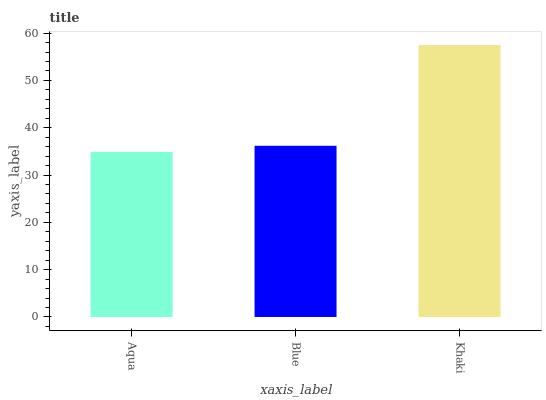Is Aqua the minimum?
Answer yes or no. Yes. Is Khaki the maximum?
Answer yes or no. Yes. Is Blue the minimum?
Answer yes or no. No. Is Blue the maximum?
Answer yes or no. No. Is Blue greater than Aqua?
Answer yes or no. Yes. Is Aqua less than Blue?
Answer yes or no. Yes. Is Aqua greater than Blue?
Answer yes or no. No. Is Blue less than Aqua?
Answer yes or no. No. Is Blue the high median?
Answer yes or no. Yes. Is Blue the low median?
Answer yes or no. Yes. Is Khaki the high median?
Answer yes or no. No. Is Khaki the low median?
Answer yes or no. No. 